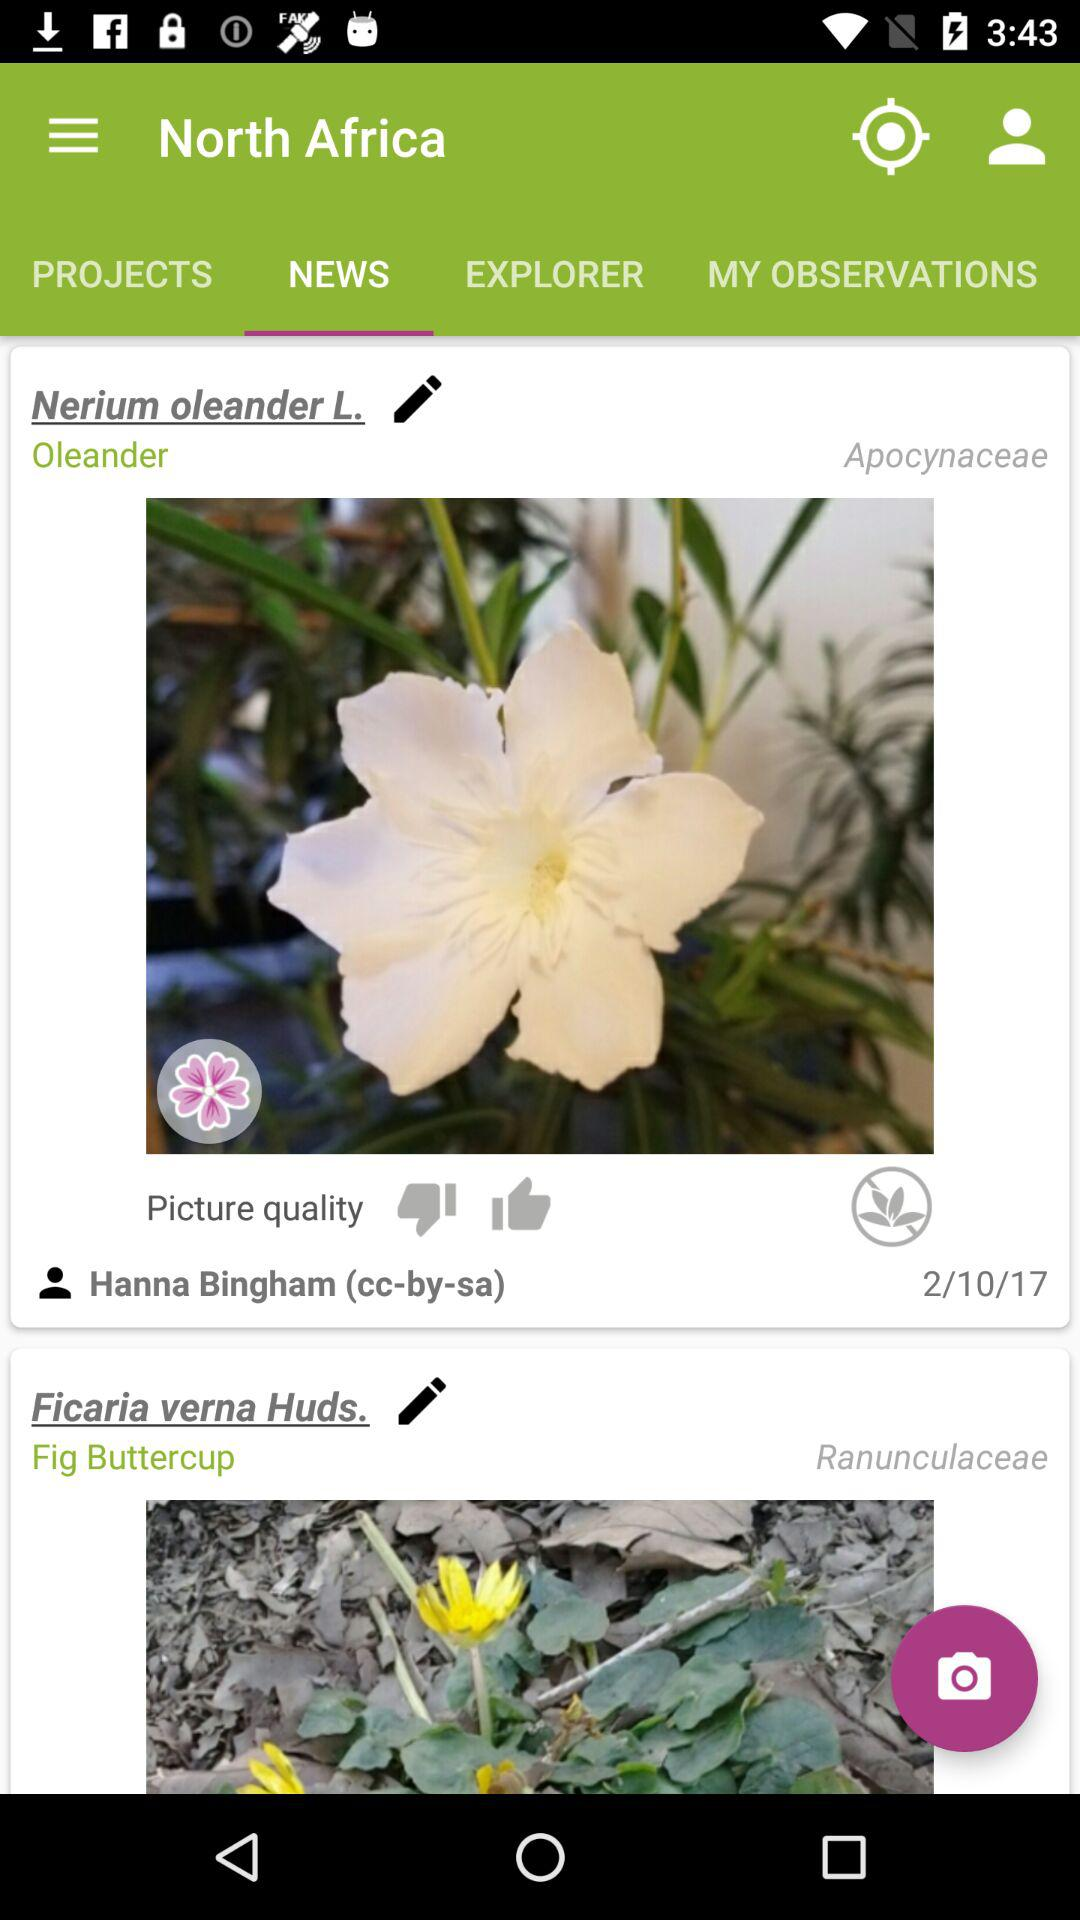What is the mentioned date? The mentioned date is February 10, 2017. 